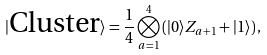<formula> <loc_0><loc_0><loc_500><loc_500>| { \text {Cluster} } \rangle = \frac { 1 } { 4 } \bigotimes _ { a = 1 } ^ { 4 } \left ( | 0 \rangle Z _ { a + 1 } + | 1 \rangle \right ) ,</formula> 